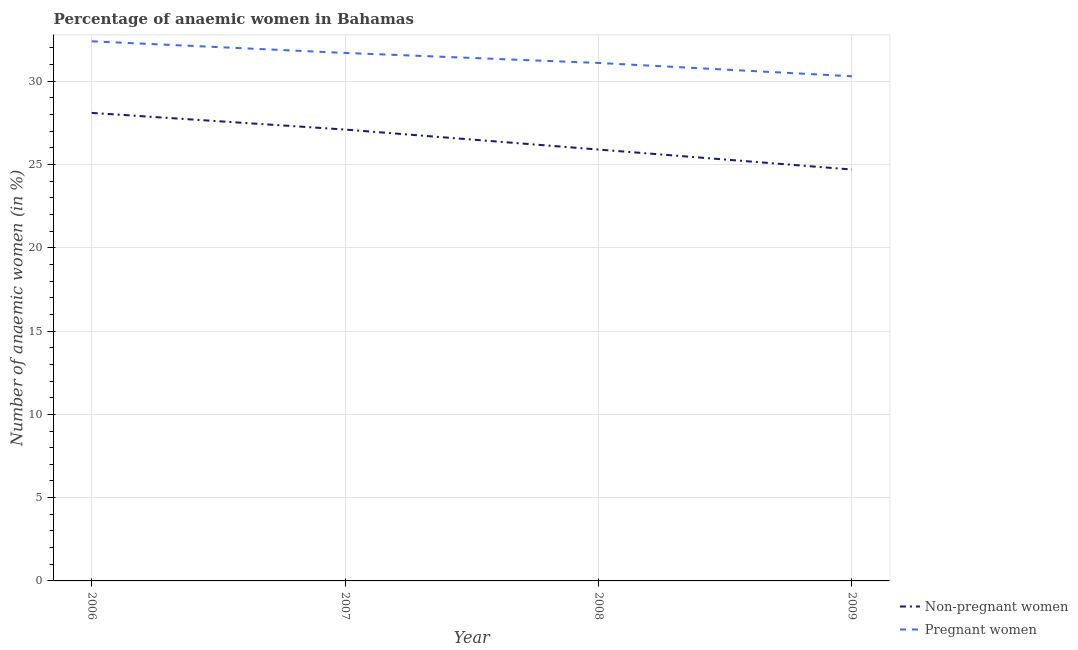How many different coloured lines are there?
Keep it short and to the point. 2. Is the number of lines equal to the number of legend labels?
Give a very brief answer. Yes. What is the percentage of non-pregnant anaemic women in 2007?
Provide a succinct answer. 27.1. Across all years, what is the maximum percentage of non-pregnant anaemic women?
Offer a very short reply. 28.1. Across all years, what is the minimum percentage of pregnant anaemic women?
Ensure brevity in your answer.  30.3. In which year was the percentage of non-pregnant anaemic women maximum?
Provide a short and direct response. 2006. What is the total percentage of pregnant anaemic women in the graph?
Your answer should be compact. 125.5. What is the difference between the percentage of non-pregnant anaemic women in 2006 and that in 2009?
Offer a very short reply. 3.4. What is the average percentage of non-pregnant anaemic women per year?
Provide a succinct answer. 26.45. In the year 2009, what is the difference between the percentage of pregnant anaemic women and percentage of non-pregnant anaemic women?
Make the answer very short. 5.6. In how many years, is the percentage of pregnant anaemic women greater than 9 %?
Provide a short and direct response. 4. What is the ratio of the percentage of non-pregnant anaemic women in 2007 to that in 2009?
Give a very brief answer. 1.1. Is the difference between the percentage of pregnant anaemic women in 2006 and 2007 greater than the difference between the percentage of non-pregnant anaemic women in 2006 and 2007?
Your response must be concise. No. What is the difference between the highest and the second highest percentage of pregnant anaemic women?
Give a very brief answer. 0.7. What is the difference between the highest and the lowest percentage of non-pregnant anaemic women?
Keep it short and to the point. 3.4. In how many years, is the percentage of non-pregnant anaemic women greater than the average percentage of non-pregnant anaemic women taken over all years?
Provide a succinct answer. 2. Is the sum of the percentage of pregnant anaemic women in 2006 and 2009 greater than the maximum percentage of non-pregnant anaemic women across all years?
Give a very brief answer. Yes. Does the percentage of pregnant anaemic women monotonically increase over the years?
Keep it short and to the point. No. Is the percentage of non-pregnant anaemic women strictly less than the percentage of pregnant anaemic women over the years?
Make the answer very short. Yes. What is the difference between two consecutive major ticks on the Y-axis?
Make the answer very short. 5. Are the values on the major ticks of Y-axis written in scientific E-notation?
Provide a succinct answer. No. How many legend labels are there?
Make the answer very short. 2. What is the title of the graph?
Make the answer very short. Percentage of anaemic women in Bahamas. Does "Quasi money growth" appear as one of the legend labels in the graph?
Your answer should be compact. No. What is the label or title of the X-axis?
Give a very brief answer. Year. What is the label or title of the Y-axis?
Provide a short and direct response. Number of anaemic women (in %). What is the Number of anaemic women (in %) of Non-pregnant women in 2006?
Ensure brevity in your answer.  28.1. What is the Number of anaemic women (in %) of Pregnant women in 2006?
Keep it short and to the point. 32.4. What is the Number of anaemic women (in %) of Non-pregnant women in 2007?
Ensure brevity in your answer.  27.1. What is the Number of anaemic women (in %) in Pregnant women in 2007?
Provide a succinct answer. 31.7. What is the Number of anaemic women (in %) in Non-pregnant women in 2008?
Provide a short and direct response. 25.9. What is the Number of anaemic women (in %) in Pregnant women in 2008?
Provide a succinct answer. 31.1. What is the Number of anaemic women (in %) of Non-pregnant women in 2009?
Give a very brief answer. 24.7. What is the Number of anaemic women (in %) of Pregnant women in 2009?
Give a very brief answer. 30.3. Across all years, what is the maximum Number of anaemic women (in %) in Non-pregnant women?
Make the answer very short. 28.1. Across all years, what is the maximum Number of anaemic women (in %) of Pregnant women?
Offer a terse response. 32.4. Across all years, what is the minimum Number of anaemic women (in %) of Non-pregnant women?
Offer a very short reply. 24.7. Across all years, what is the minimum Number of anaemic women (in %) of Pregnant women?
Offer a terse response. 30.3. What is the total Number of anaemic women (in %) of Non-pregnant women in the graph?
Offer a terse response. 105.8. What is the total Number of anaemic women (in %) in Pregnant women in the graph?
Make the answer very short. 125.5. What is the difference between the Number of anaemic women (in %) in Pregnant women in 2006 and that in 2007?
Give a very brief answer. 0.7. What is the difference between the Number of anaemic women (in %) in Pregnant women in 2006 and that in 2008?
Your response must be concise. 1.3. What is the difference between the Number of anaemic women (in %) of Non-pregnant women in 2006 and that in 2009?
Offer a very short reply. 3.4. What is the difference between the Number of anaemic women (in %) in Non-pregnant women in 2007 and that in 2008?
Offer a very short reply. 1.2. What is the difference between the Number of anaemic women (in %) in Pregnant women in 2007 and that in 2008?
Give a very brief answer. 0.6. What is the difference between the Number of anaemic women (in %) in Non-pregnant women in 2007 and that in 2009?
Offer a terse response. 2.4. What is the difference between the Number of anaemic women (in %) in Non-pregnant women in 2008 and that in 2009?
Offer a terse response. 1.2. What is the difference between the Number of anaemic women (in %) in Pregnant women in 2008 and that in 2009?
Give a very brief answer. 0.8. What is the difference between the Number of anaemic women (in %) of Non-pregnant women in 2006 and the Number of anaemic women (in %) of Pregnant women in 2007?
Provide a short and direct response. -3.6. What is the difference between the Number of anaemic women (in %) in Non-pregnant women in 2006 and the Number of anaemic women (in %) in Pregnant women in 2009?
Your response must be concise. -2.2. What is the difference between the Number of anaemic women (in %) of Non-pregnant women in 2007 and the Number of anaemic women (in %) of Pregnant women in 2008?
Provide a succinct answer. -4. What is the difference between the Number of anaemic women (in %) of Non-pregnant women in 2007 and the Number of anaemic women (in %) of Pregnant women in 2009?
Provide a succinct answer. -3.2. What is the difference between the Number of anaemic women (in %) in Non-pregnant women in 2008 and the Number of anaemic women (in %) in Pregnant women in 2009?
Your answer should be very brief. -4.4. What is the average Number of anaemic women (in %) of Non-pregnant women per year?
Keep it short and to the point. 26.45. What is the average Number of anaemic women (in %) in Pregnant women per year?
Provide a succinct answer. 31.38. What is the ratio of the Number of anaemic women (in %) of Non-pregnant women in 2006 to that in 2007?
Ensure brevity in your answer.  1.04. What is the ratio of the Number of anaemic women (in %) of Pregnant women in 2006 to that in 2007?
Give a very brief answer. 1.02. What is the ratio of the Number of anaemic women (in %) of Non-pregnant women in 2006 to that in 2008?
Offer a terse response. 1.08. What is the ratio of the Number of anaemic women (in %) of Pregnant women in 2006 to that in 2008?
Make the answer very short. 1.04. What is the ratio of the Number of anaemic women (in %) of Non-pregnant women in 2006 to that in 2009?
Provide a succinct answer. 1.14. What is the ratio of the Number of anaemic women (in %) of Pregnant women in 2006 to that in 2009?
Provide a succinct answer. 1.07. What is the ratio of the Number of anaemic women (in %) in Non-pregnant women in 2007 to that in 2008?
Provide a short and direct response. 1.05. What is the ratio of the Number of anaemic women (in %) in Pregnant women in 2007 to that in 2008?
Offer a terse response. 1.02. What is the ratio of the Number of anaemic women (in %) of Non-pregnant women in 2007 to that in 2009?
Offer a terse response. 1.1. What is the ratio of the Number of anaemic women (in %) of Pregnant women in 2007 to that in 2009?
Make the answer very short. 1.05. What is the ratio of the Number of anaemic women (in %) in Non-pregnant women in 2008 to that in 2009?
Keep it short and to the point. 1.05. What is the ratio of the Number of anaemic women (in %) of Pregnant women in 2008 to that in 2009?
Offer a very short reply. 1.03. What is the difference between the highest and the second highest Number of anaemic women (in %) in Non-pregnant women?
Make the answer very short. 1. What is the difference between the highest and the lowest Number of anaemic women (in %) in Non-pregnant women?
Your response must be concise. 3.4. 